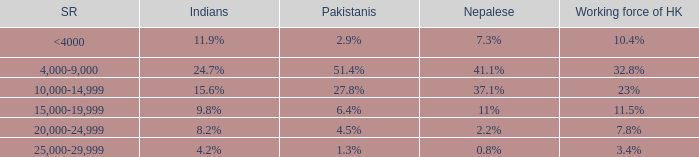If the salary range is 4,000-9,000, what is the Indians %? 24.7%. 